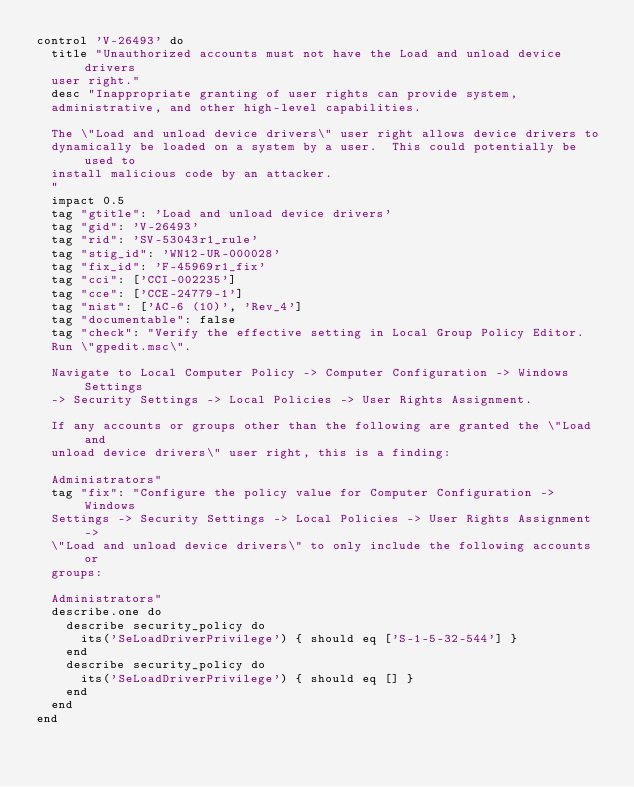<code> <loc_0><loc_0><loc_500><loc_500><_Ruby_>control 'V-26493' do
  title "Unauthorized accounts must not have the Load and unload device drivers
  user right."
  desc "Inappropriate granting of user rights can provide system,
  administrative, and other high-level capabilities.

  The \"Load and unload device drivers\" user right allows device drivers to
  dynamically be loaded on a system by a user.  This could potentially be used to
  install malicious code by an attacker.
  "
  impact 0.5
  tag "gtitle": 'Load and unload device drivers'
  tag "gid": 'V-26493'
  tag "rid": 'SV-53043r1_rule'
  tag "stig_id": 'WN12-UR-000028'
  tag "fix_id": 'F-45969r1_fix'
  tag "cci": ['CCI-002235']
  tag "cce": ['CCE-24779-1']
  tag "nist": ['AC-6 (10)', 'Rev_4']
  tag "documentable": false
  tag "check": "Verify the effective setting in Local Group Policy Editor.
  Run \"gpedit.msc\".

  Navigate to Local Computer Policy -> Computer Configuration -> Windows Settings
  -> Security Settings -> Local Policies -> User Rights Assignment.

  If any accounts or groups other than the following are granted the \"Load and
  unload device drivers\" user right, this is a finding:

  Administrators"
  tag "fix": "Configure the policy value for Computer Configuration -> Windows
  Settings -> Security Settings -> Local Policies -> User Rights Assignment ->
  \"Load and unload device drivers\" to only include the following accounts or
  groups:

  Administrators"
  describe.one do
    describe security_policy do
      its('SeLoadDriverPrivilege') { should eq ['S-1-5-32-544'] }
    end
    describe security_policy do
      its('SeLoadDriverPrivilege') { should eq [] }
    end
  end
end
</code> 